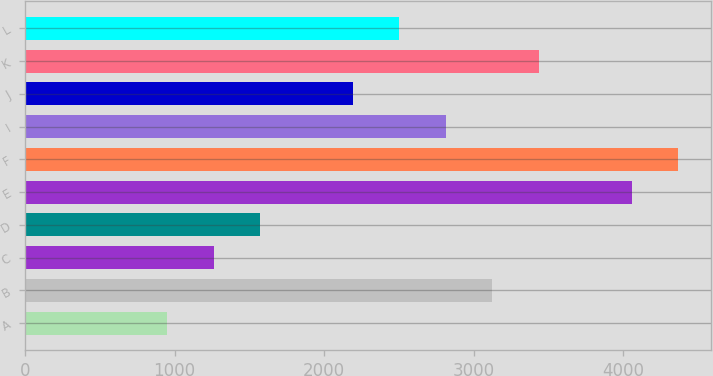<chart> <loc_0><loc_0><loc_500><loc_500><bar_chart><fcel>A<fcel>B<fcel>C<fcel>D<fcel>E<fcel>F<fcel>I<fcel>J<fcel>K<fcel>L<nl><fcel>950.51<fcel>3124.01<fcel>1261.01<fcel>1571.51<fcel>4055.55<fcel>4366.05<fcel>2813.51<fcel>2192.51<fcel>3434.51<fcel>2503.01<nl></chart> 